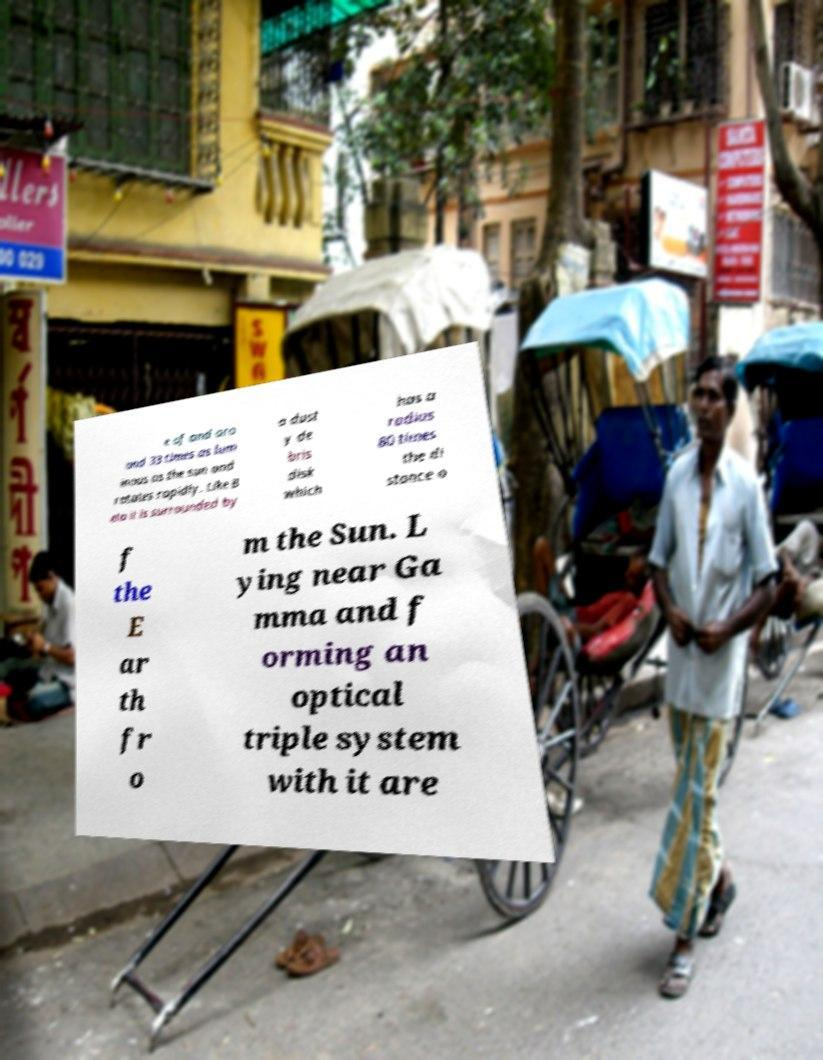Can you read and provide the text displayed in the image?This photo seems to have some interesting text. Can you extract and type it out for me? e of and aro und 33 times as lum inous as the sun and rotates rapidly. Like B eta it is surrounded by a dust y de bris disk which has a radius 80 times the di stance o f the E ar th fr o m the Sun. L ying near Ga mma and f orming an optical triple system with it are 